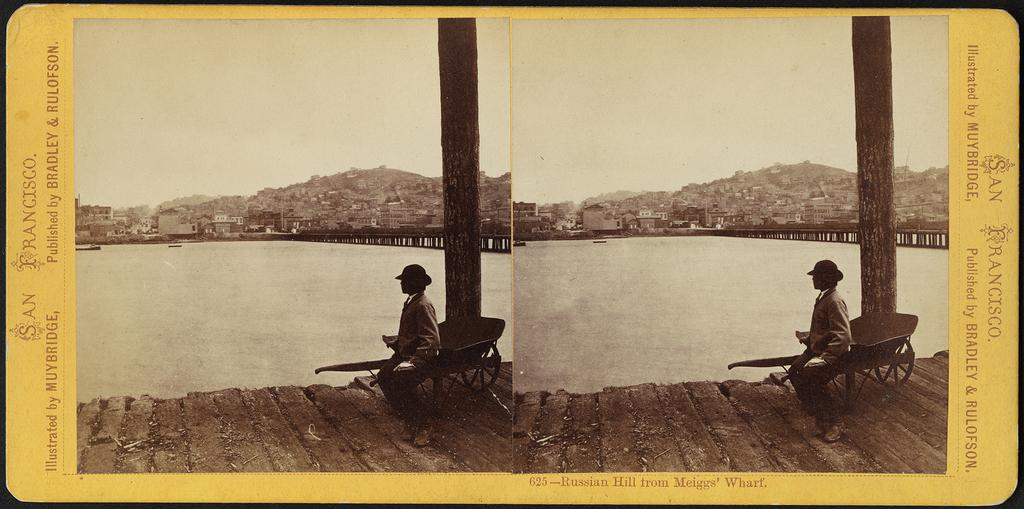What type of image is shown? The image is edited and a collage of two similar pictures. What can be observed about the background of the pictures? The pictures have a similar background. What is the person in the image doing? The person is sitting on a chair in the image. Where is the person sitting? The person is sitting on a bridge. What is the bridge situated near? The bridge is in front of a river. What type of game is being played on the table in the image? There is no table or game present in the image; it features a person sitting on a bridge in front of a river. 